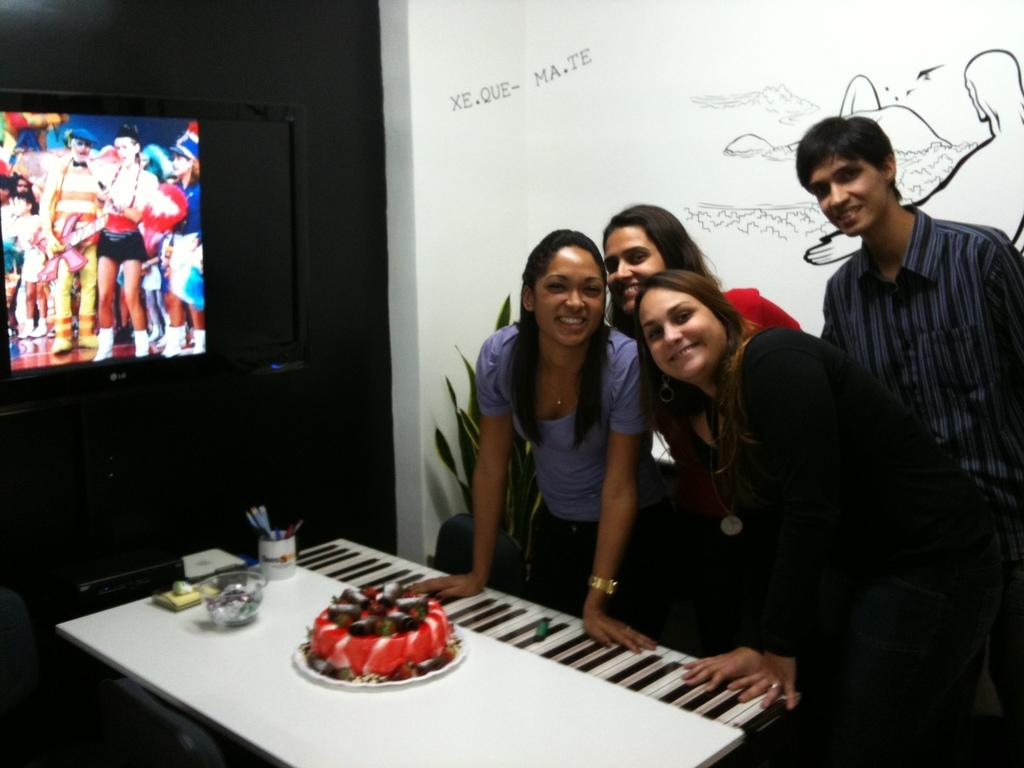What can be seen in the image involving people? There are people standing in the image. What is on the table in the image? There is a cake and a pen stand on the table. What is on the wall in the image? There is a TV screen on the wall. Are there any snakes visible in the image? No, there are no snakes present in the image. What company is hosting the event shown in the image? The provided facts do not mention any company or event, so we cannot determine the company hosting the event. 